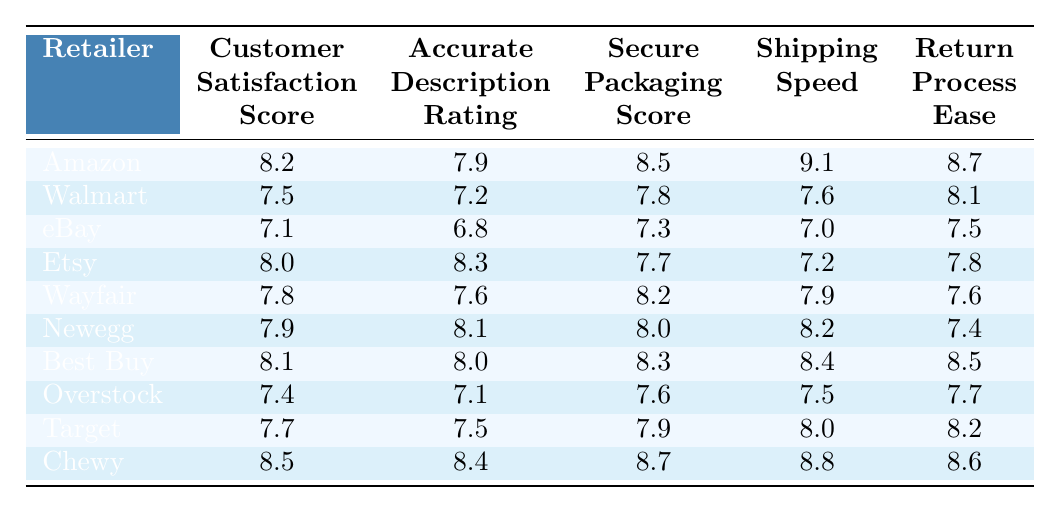What is the customer satisfaction score for Amazon? According to the table, Amazon's customer satisfaction score is listed under the "Customer Satisfaction Score" column, which reads 8.2.
Answer: 8.2 What retailer has the highest secure packaging score? The table displays Chewy with a secure packaging score of 8.7, which is the highest value listed in the "Secure Packaging Score" column.
Answer: Chewy Is the accurate description rating for eBay lower than for Walmart? The accurate description rating for eBay is 6.8, while Walmart's is 7.2. Since 6.8 is less than 7.2, the statement is true.
Answer: Yes Which retailer has the quickest shipping speed? Looking at the "Shipping Speed" column, Amazon has the highest score of 9.1, indicating it has the quickest shipping speed.
Answer: Amazon What is the average customer satisfaction score for all retailers? The scores are: 8.2, 7.5, 7.1, 8.0, 7.8, 7.9, 8.1, 7.4, 7.7, 8.5. Adding these together gives 79.2, and dividing by 10 yields an average of 7.92.
Answer: 7.9 Is the return process ease for Best Buy higher than for Target? Best Buy has a return process ease score of 8.5, while Target's score is 8.2. Since 8.5 is greater than 8.2, the statement is true.
Answer: Yes What is the difference between the accurate description rating of Amazon and Newegg? Amazon’s accurate description rating is 7.9, and Newegg’s is 8.1. The difference is 8.1 - 7.9 = 0.2.
Answer: 0.2 Which retailer ranks second in terms of customer satisfaction score? Comparing all scores, Chewy ranks first with 8.5, followed by Amazon with 8.2. So, the second place goes to Amazon.
Answer: Amazon How does the secure packaging score for Etsy compare to Newegg? Etsy's secure packaging score is 7.7, while Newegg's is 8.0. Since 7.7 is less than 8.0, Etsy has a lower score.
Answer: Lower What is the sum of the shipping speed scores for Walmart and eBay? Walmart’s shipping speed score is 7.6, and eBay’s is 7.0. Adding these scores results in 7.6 + 7.0 = 14.6.
Answer: 14.6 